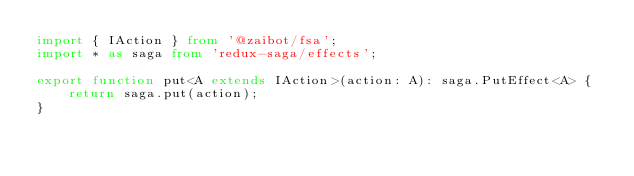Convert code to text. <code><loc_0><loc_0><loc_500><loc_500><_TypeScript_>import { IAction } from '@zaibot/fsa';
import * as saga from 'redux-saga/effects';

export function put<A extends IAction>(action: A): saga.PutEffect<A> {
    return saga.put(action);
}
</code> 